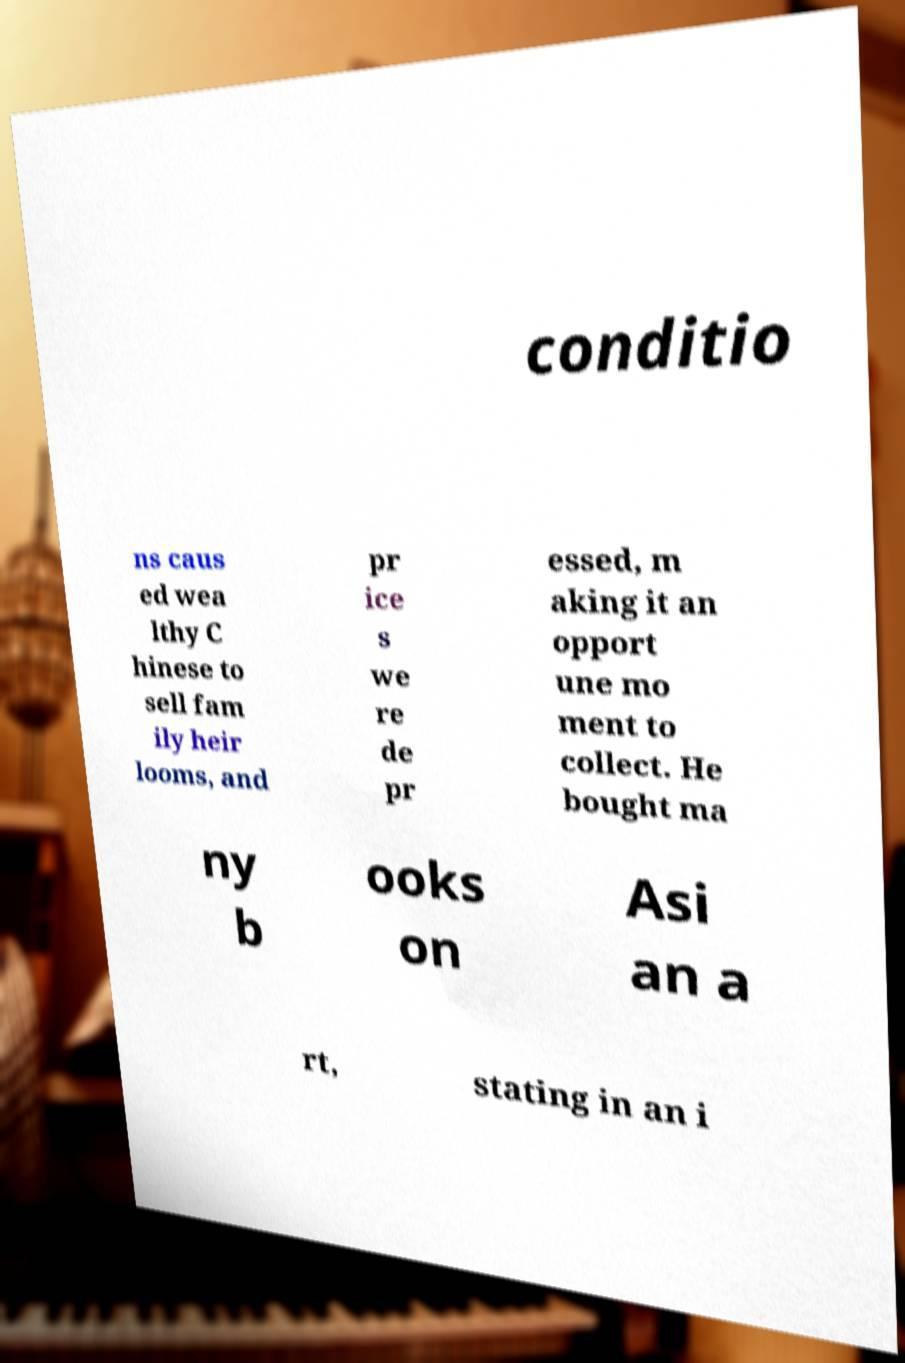I need the written content from this picture converted into text. Can you do that? conditio ns caus ed wea lthy C hinese to sell fam ily heir looms, and pr ice s we re de pr essed, m aking it an opport une mo ment to collect. He bought ma ny b ooks on Asi an a rt, stating in an i 